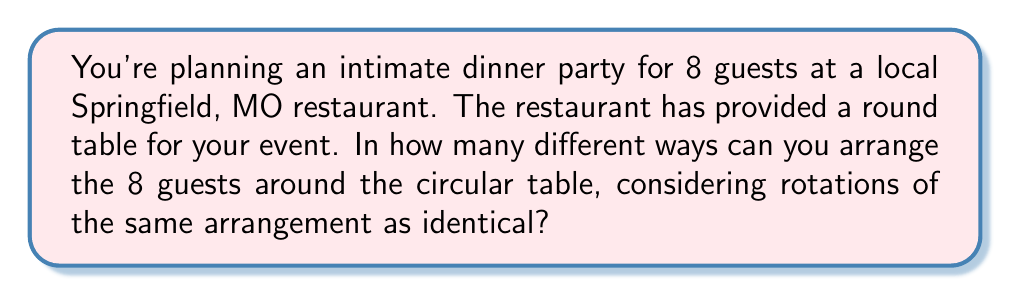Show me your answer to this math problem. Let's approach this step-by-step:

1) First, we need to recognize that this is a circular permutation problem. In a circular arrangement, rotations of the same arrangement are considered identical.

2) For a linear arrangement of 8 people, we would use the factorial formula: 8! (8 factorial).

3) However, for a circular arrangement, we need to divide by the number of rotations possible, which is equal to the number of people being arranged.

4) The formula for circular permutations is:

   $$(n-1)!$$

   Where n is the number of objects (in this case, people) being arranged.

5) In our case, n = 8, so we calculate:

   $$(8-1)! = 7!$$

6) Let's compute this:
   
   $$7! = 7 \times 6 \times 5 \times 4 \times 3 \times 2 \times 1 = 5040$$

Therefore, there are 5040 different ways to arrange 8 guests around the circular table.
Answer: 5040 